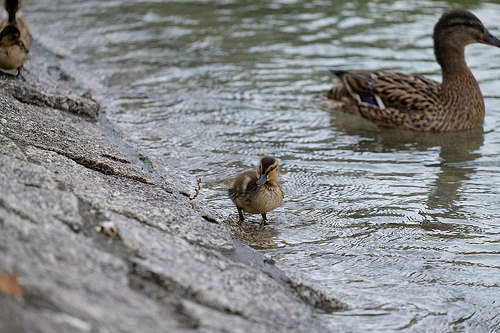<image>
Is the mother duck to the left of the baby duck? Yes. From this viewpoint, the mother duck is positioned to the left side relative to the baby duck. 